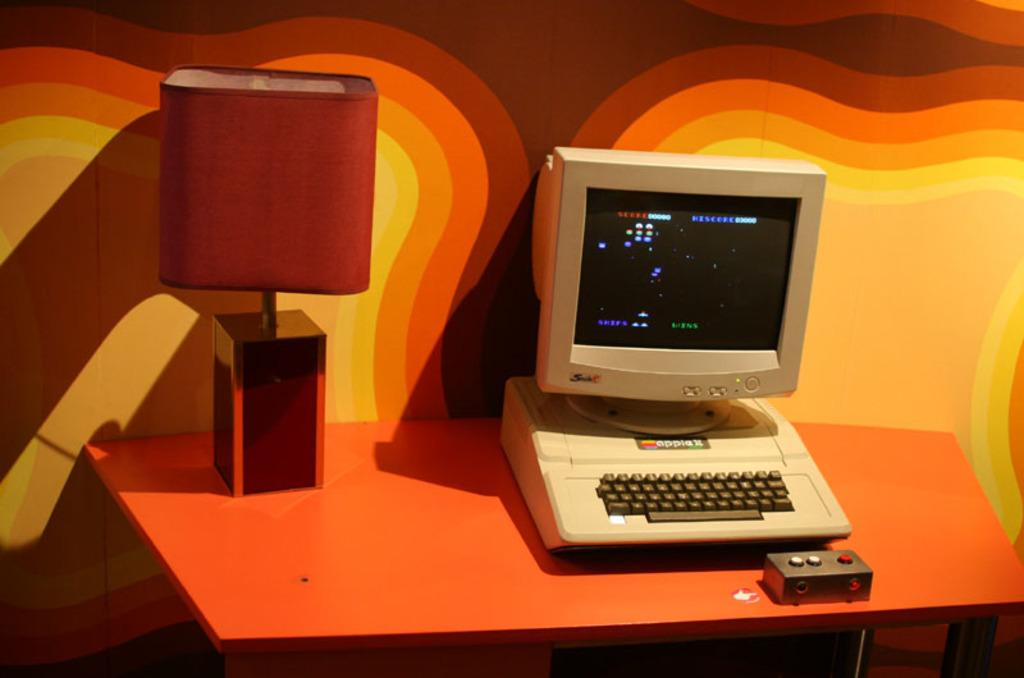What type of furniture is present in the image? There is a table in the image. What object is placed on the table? A computer is placed on the table. Is there any additional item on the table? Yes, there is a table lamp on the table. What type of story is the pet telling in the shop in the image? There is no pet, story, or shop present in the image. The image only features a table with a computer and a table lamp on it. 